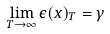Convert formula to latex. <formula><loc_0><loc_0><loc_500><loc_500>\lim _ { T \rightarrow \infty } \epsilon ( x ) _ { T } = \gamma</formula> 